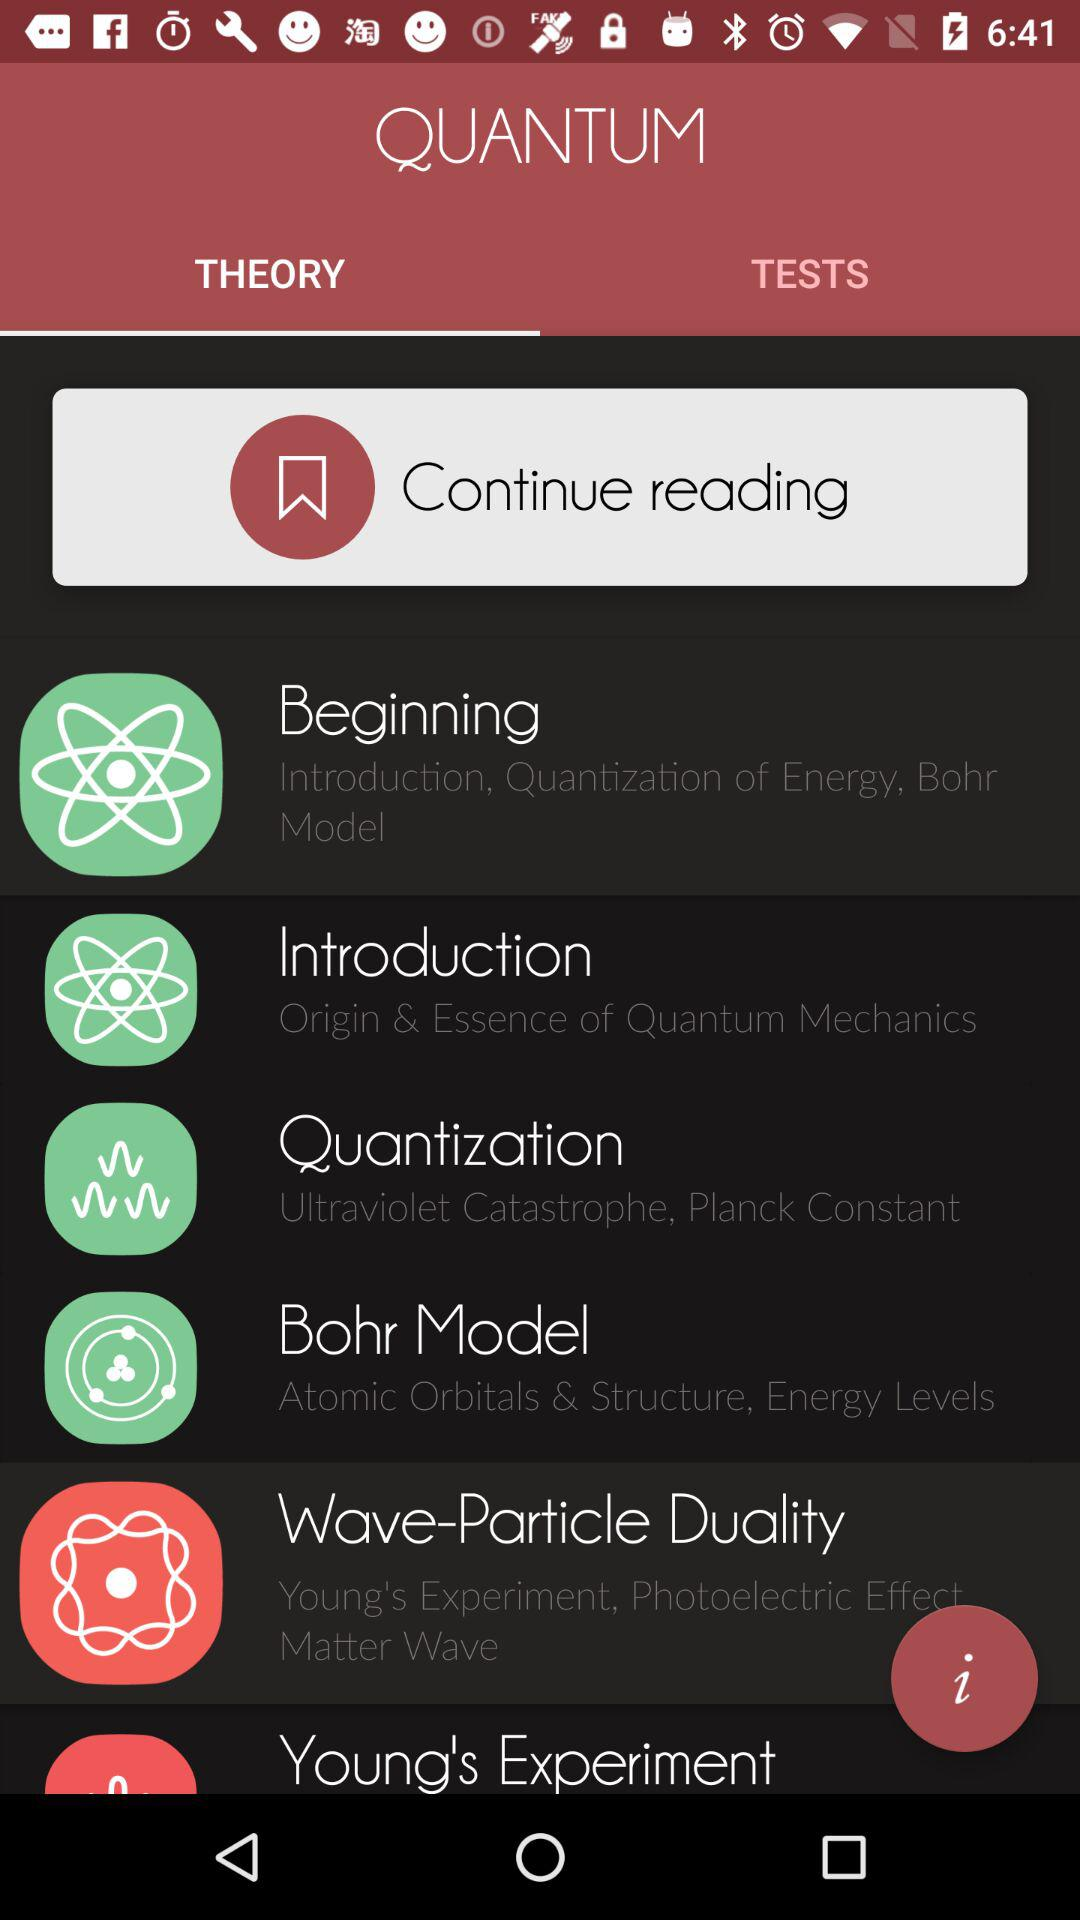How many questions are in each test?
When the provided information is insufficient, respond with <no answer>. <no answer> 